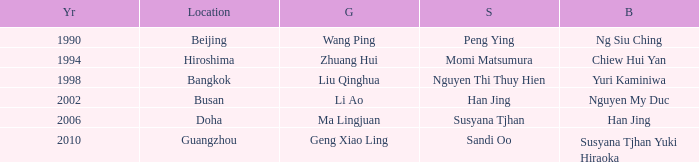What Silver has a Golf of Li AO? Han Jing. 